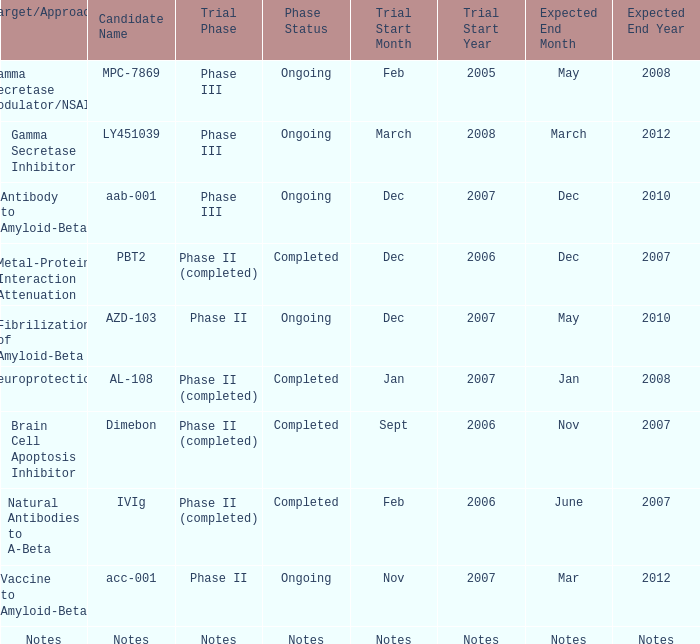Parse the table in full. {'header': ['Target/Approach', 'Candidate Name', 'Trial Phase', 'Phase Status', 'Trial Start Month', 'Trial Start Year', 'Expected End Month', 'Expected End Year'], 'rows': [['Gamma Secretase Modulator/NSAID', 'MPC-7869', 'Phase III', 'Ongoing', 'Feb', '2005', 'May', '2008'], ['Gamma Secretase Inhibitor', 'LY451039', 'Phase III', 'Ongoing', 'March', '2008', 'March', '2012'], ['Antibody to Amyloid-Beta', 'aab-001', 'Phase III', 'Ongoing', 'Dec', '2007', 'Dec', '2010'], ['Metal-Protein Interaction Attenuation', 'PBT2', 'Phase II (completed)', 'Completed', 'Dec', '2006', 'Dec', '2007'], ['Fibrilization of Amyloid-Beta', 'AZD-103', 'Phase II', 'Ongoing', 'Dec', '2007', 'May', '2010'], ['Neuroprotection', 'AL-108', 'Phase II (completed)', 'Completed', 'Jan', '2007', 'Jan', '2008'], ['Brain Cell Apoptosis Inhibitor', 'Dimebon', 'Phase II (completed)', 'Completed', 'Sept', '2006', 'Nov', '2007'], ['Natural Antibodies to A-Beta', 'IVIg', 'Phase II (completed)', 'Completed', 'Feb', '2006', 'June', '2007'], ['Vaccine to Amyloid-Beta', 'acc-001', 'Phase II', 'Ongoing', 'Nov', '2007', 'Mar', '2012'], ['Notes', 'Notes', 'Notes', 'Notes', 'Notes', 'Notes', 'Notes', 'Notes']]} What is Expected End Date, when Trial Start Date is Nov 2007? Mar 2012. 